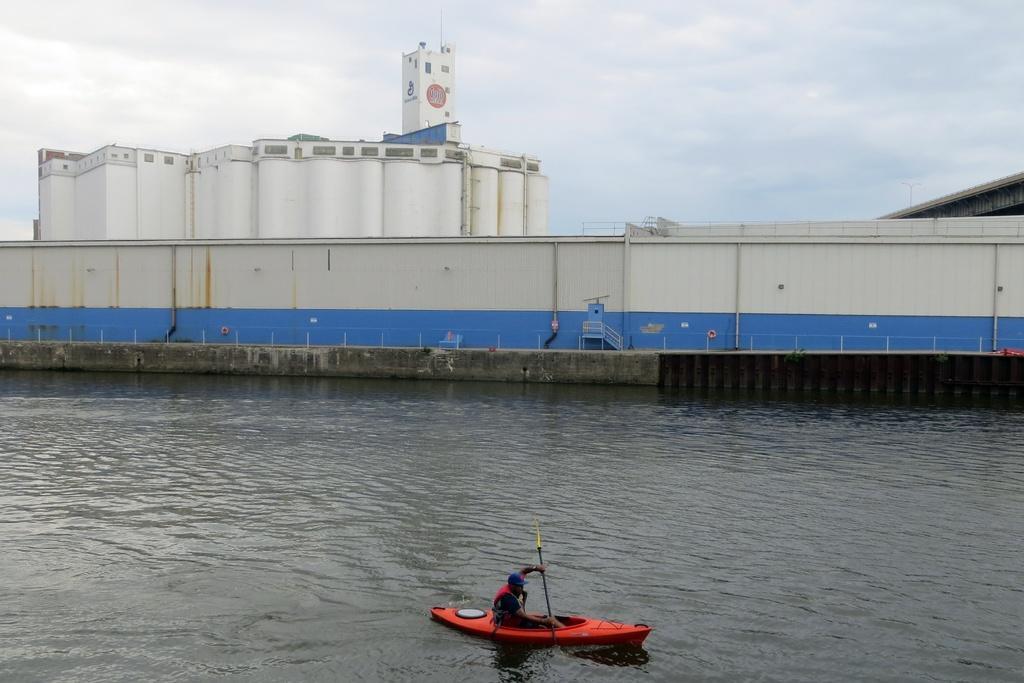Could you give a brief overview of what you see in this image? In this picture I can see there is a person sitting in the boat and sailing on the water and there is a building in the backdrop and the sky is clear. 